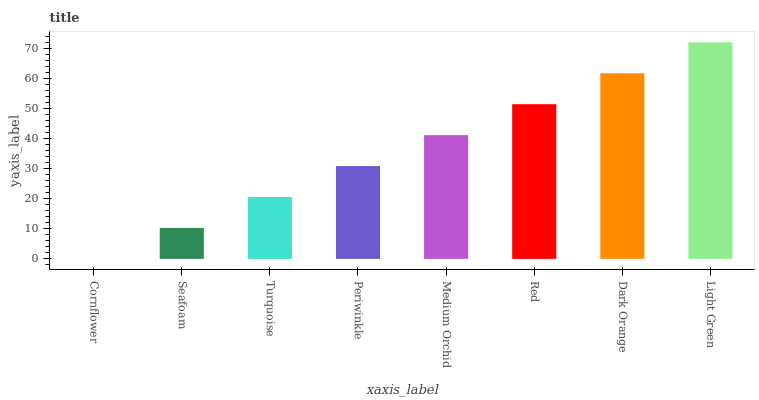Is Seafoam the minimum?
Answer yes or no. No. Is Seafoam the maximum?
Answer yes or no. No. Is Seafoam greater than Cornflower?
Answer yes or no. Yes. Is Cornflower less than Seafoam?
Answer yes or no. Yes. Is Cornflower greater than Seafoam?
Answer yes or no. No. Is Seafoam less than Cornflower?
Answer yes or no. No. Is Medium Orchid the high median?
Answer yes or no. Yes. Is Periwinkle the low median?
Answer yes or no. Yes. Is Dark Orange the high median?
Answer yes or no. No. Is Red the low median?
Answer yes or no. No. 